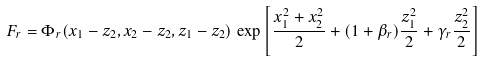<formula> <loc_0><loc_0><loc_500><loc_500>F _ { r } = \Phi _ { r } ( x _ { 1 } - z _ { 2 } , x _ { 2 } - z _ { 2 } , z _ { 1 } - z _ { 2 } ) \, \exp \left [ \frac { x _ { 1 } ^ { 2 } + x _ { 2 } ^ { 2 } } { 2 } + ( 1 + \beta _ { r } ) \frac { z _ { 1 } ^ { 2 } } { 2 } + \gamma _ { r } \frac { z _ { 2 } ^ { 2 } } { 2 } \right ]</formula> 